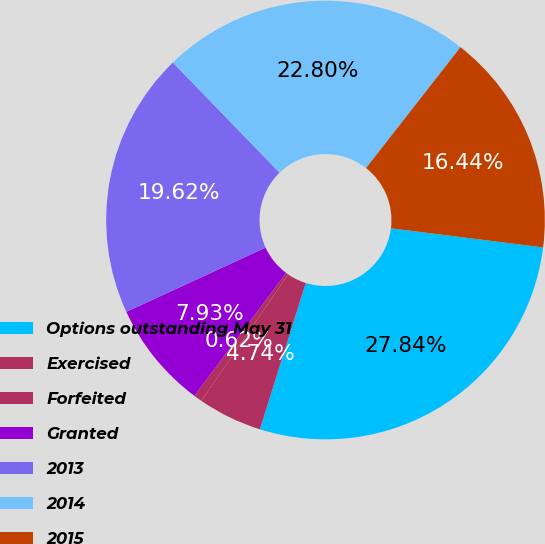Convert chart to OTSL. <chart><loc_0><loc_0><loc_500><loc_500><pie_chart><fcel>Options outstanding May 31<fcel>Exercised<fcel>Forfeited<fcel>Granted<fcel>2013<fcel>2014<fcel>2015<nl><fcel>27.84%<fcel>4.74%<fcel>0.62%<fcel>7.93%<fcel>19.62%<fcel>22.8%<fcel>16.44%<nl></chart> 